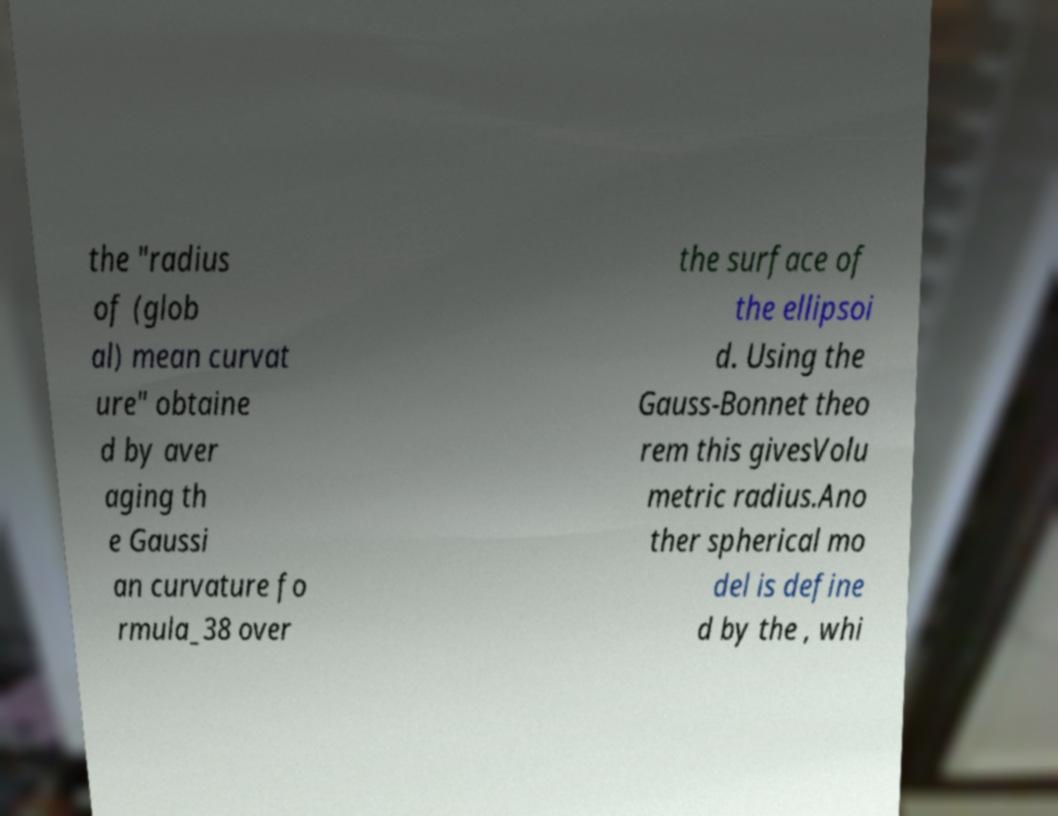I need the written content from this picture converted into text. Can you do that? the "radius of (glob al) mean curvat ure" obtaine d by aver aging th e Gaussi an curvature fo rmula_38 over the surface of the ellipsoi d. Using the Gauss-Bonnet theo rem this givesVolu metric radius.Ano ther spherical mo del is define d by the , whi 